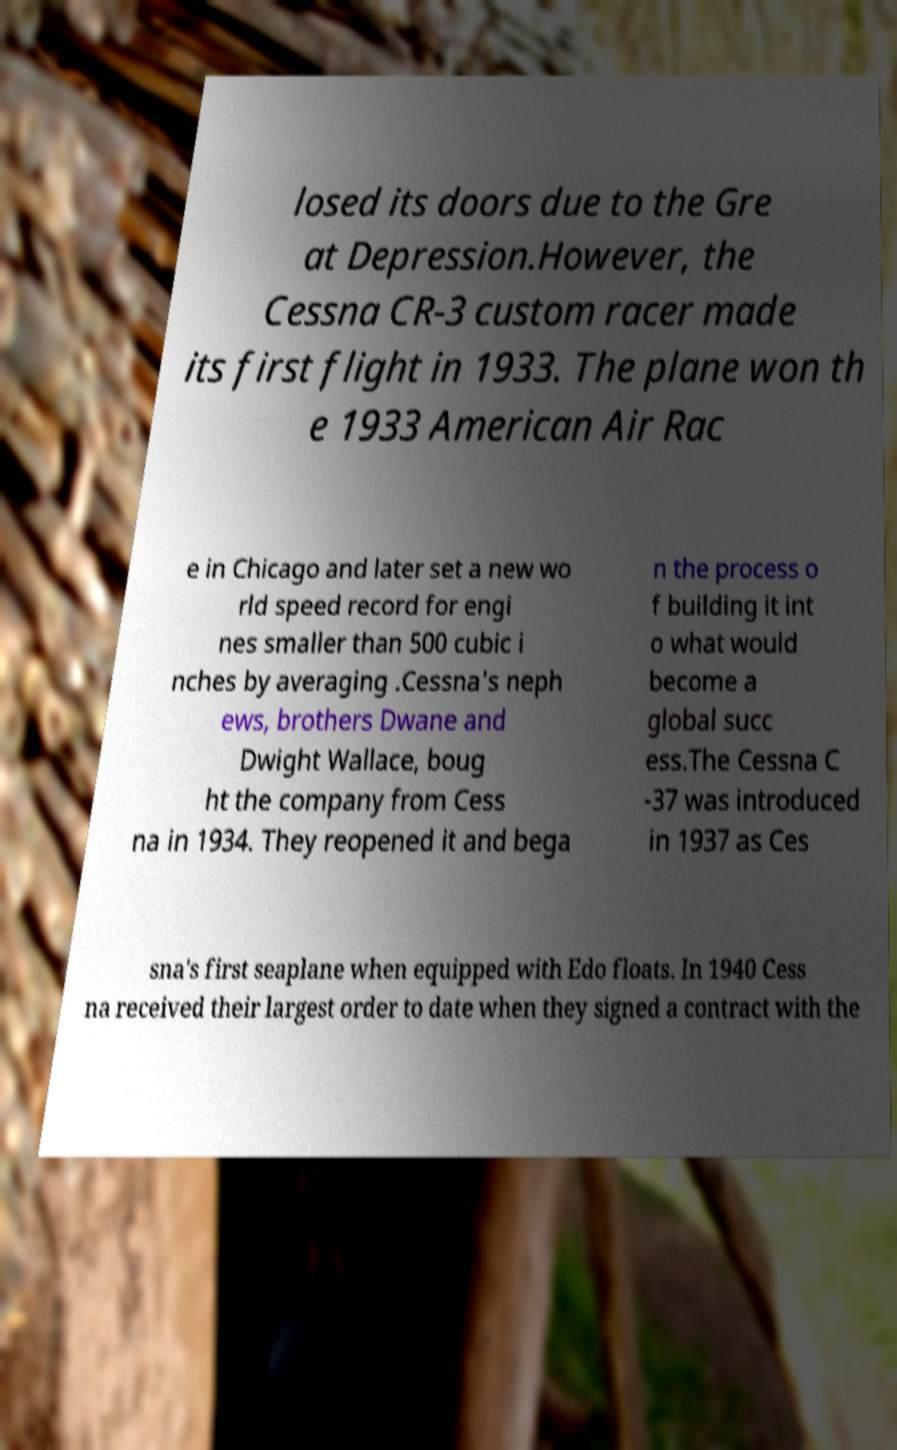Can you read and provide the text displayed in the image?This photo seems to have some interesting text. Can you extract and type it out for me? losed its doors due to the Gre at Depression.However, the Cessna CR-3 custom racer made its first flight in 1933. The plane won th e 1933 American Air Rac e in Chicago and later set a new wo rld speed record for engi nes smaller than 500 cubic i nches by averaging .Cessna's neph ews, brothers Dwane and Dwight Wallace, boug ht the company from Cess na in 1934. They reopened it and bega n the process o f building it int o what would become a global succ ess.The Cessna C -37 was introduced in 1937 as Ces sna's first seaplane when equipped with Edo floats. In 1940 Cess na received their largest order to date when they signed a contract with the 